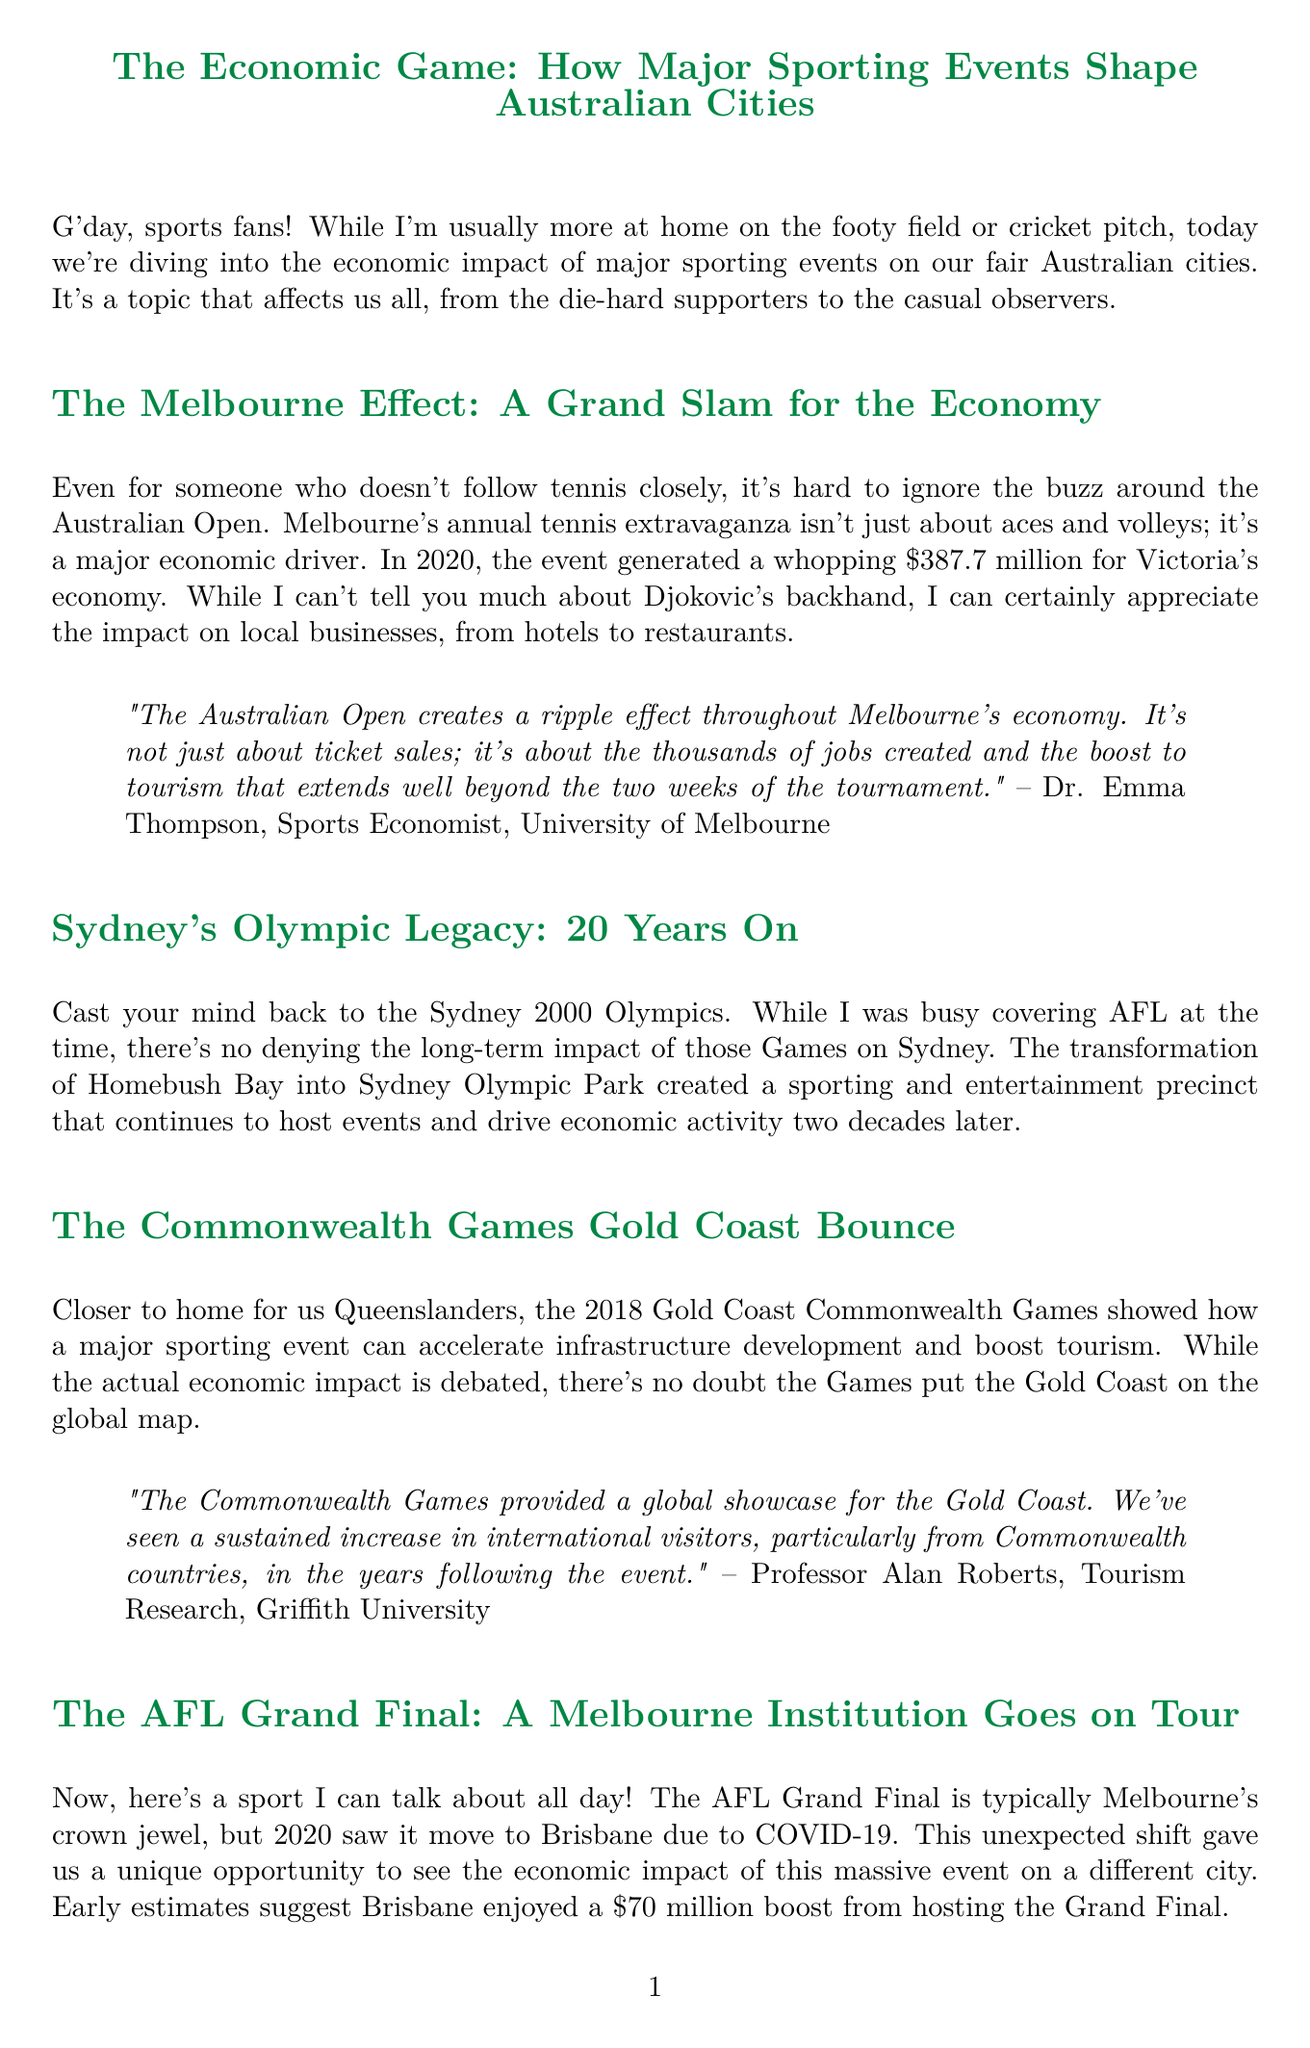What was the economic impact of the Australian Open in 2020? The document states that the Australian Open generated a whopping $387.7 million for Victoria's economy in 2020.
Answer: $387.7 million How many annual visitors does Sydney Olympic Park attract? The infographic in the document lists that Sydney Olympic Park attracts over 10 million visitors annually.
Answer: 10 million+ Who is the expert quoted regarding the economic impact of the Commonwealth Games? The document mentions Professor Alan Roberts from Griffith University as the expert providing insights about the Commonwealth Games.
Answer: Professor Alan Roberts What was the estimated economic benefit to Brisbane from hosting the AFL Grand Final in 2020? The document states that early estimates suggest Brisbane enjoyed a $70 million boost from hosting the Grand Final in 2020.
Answer: $70 million What year did the Sydney Olympics take place? The section on Sydney's Olympic legacy refers to the Sydney 2000 Olympics.
Answer: 2000 What is the expected economic contribution of the 2032 Brisbane Olympics? Dr. Sarah Chen mentions that the Olympics present a unique opportunity for lasting economic benefits similar to Sydney's experience, though no specific number is given.
Answer: Unique opportunity for lasting economic benefits How many major events does Sydney Olympic Park host annually? The infographic shows that Sydney Olympic Park hosts over 5,000 major events annually.
Answer: 5,000+ What city hosted the AFL Grand Final in 2020? The document indicates that the AFL Grand Final moved to Brisbane in 2020 due to COVID-19.
Answer: Brisbane 